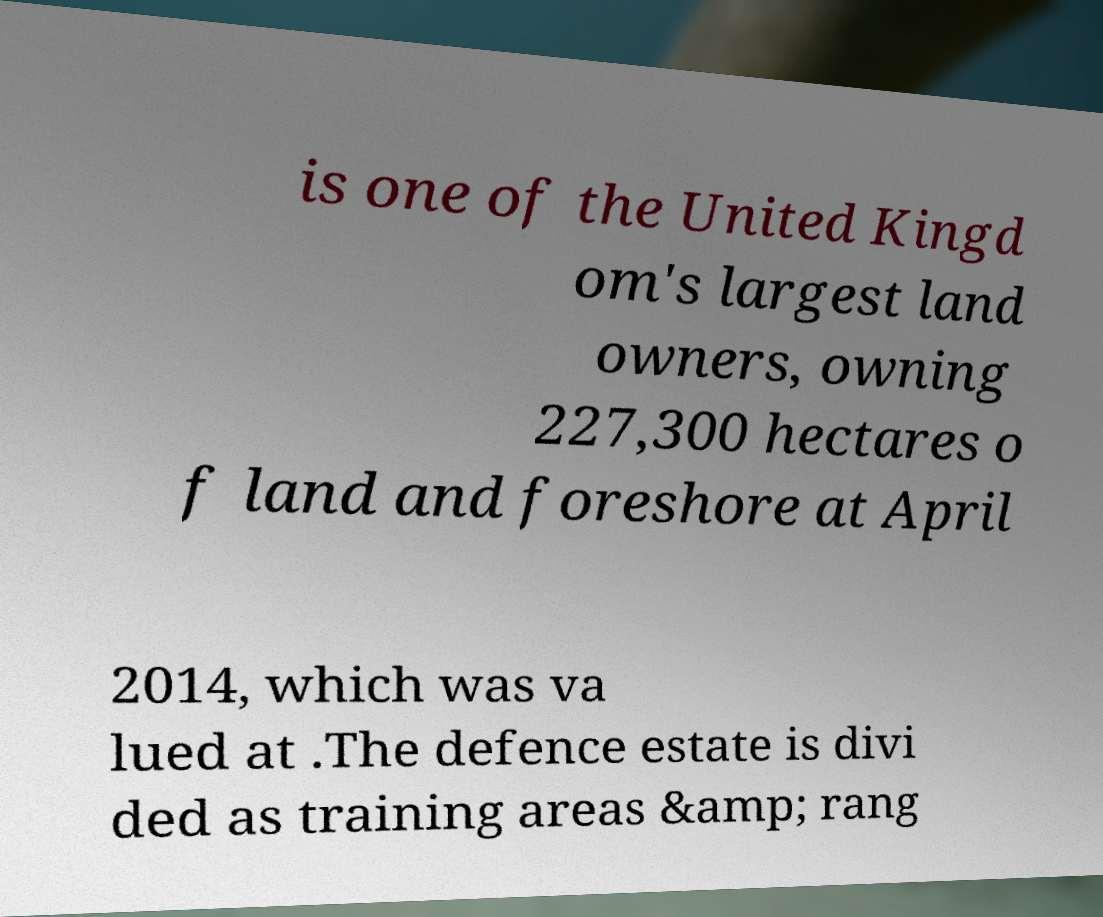Can you accurately transcribe the text from the provided image for me? is one of the United Kingd om's largest land owners, owning 227,300 hectares o f land and foreshore at April 2014, which was va lued at .The defence estate is divi ded as training areas &amp; rang 